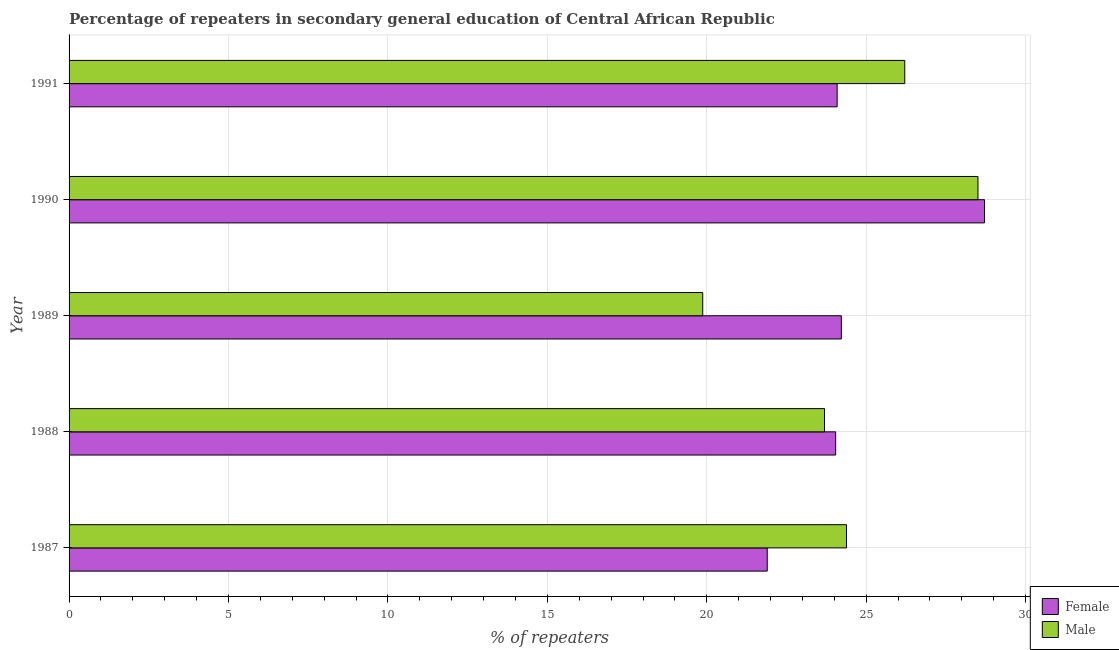How many different coloured bars are there?
Provide a succinct answer. 2. How many groups of bars are there?
Your response must be concise. 5. Are the number of bars per tick equal to the number of legend labels?
Provide a succinct answer. Yes. What is the percentage of female repeaters in 1988?
Provide a short and direct response. 24.04. Across all years, what is the maximum percentage of female repeaters?
Provide a short and direct response. 28.71. Across all years, what is the minimum percentage of female repeaters?
Ensure brevity in your answer.  21.9. What is the total percentage of female repeaters in the graph?
Your answer should be compact. 122.96. What is the difference between the percentage of female repeaters in 1987 and that in 1990?
Make the answer very short. -6.82. What is the difference between the percentage of female repeaters in 1990 and the percentage of male repeaters in 1991?
Offer a very short reply. 2.5. What is the average percentage of male repeaters per year?
Ensure brevity in your answer.  24.53. In the year 1991, what is the difference between the percentage of female repeaters and percentage of male repeaters?
Offer a terse response. -2.12. What is the ratio of the percentage of female repeaters in 1987 to that in 1989?
Ensure brevity in your answer.  0.9. What is the difference between the highest and the second highest percentage of female repeaters?
Ensure brevity in your answer.  4.49. What is the difference between the highest and the lowest percentage of female repeaters?
Your response must be concise. 6.82. What does the 2nd bar from the bottom in 1989 represents?
Make the answer very short. Male. How many years are there in the graph?
Keep it short and to the point. 5. Does the graph contain any zero values?
Your answer should be compact. No. Does the graph contain grids?
Your answer should be compact. Yes. What is the title of the graph?
Provide a short and direct response. Percentage of repeaters in secondary general education of Central African Republic. Does "DAC donors" appear as one of the legend labels in the graph?
Your answer should be very brief. No. What is the label or title of the X-axis?
Your response must be concise. % of repeaters. What is the % of repeaters in Female in 1987?
Ensure brevity in your answer.  21.9. What is the % of repeaters of Male in 1987?
Your answer should be compact. 24.38. What is the % of repeaters of Female in 1988?
Your response must be concise. 24.04. What is the % of repeaters of Male in 1988?
Your answer should be very brief. 23.69. What is the % of repeaters in Female in 1989?
Provide a succinct answer. 24.22. What is the % of repeaters of Male in 1989?
Provide a succinct answer. 19.87. What is the % of repeaters in Female in 1990?
Your answer should be very brief. 28.71. What is the % of repeaters of Male in 1990?
Give a very brief answer. 28.51. What is the % of repeaters of Female in 1991?
Give a very brief answer. 24.09. What is the % of repeaters of Male in 1991?
Make the answer very short. 26.21. Across all years, what is the maximum % of repeaters in Female?
Offer a terse response. 28.71. Across all years, what is the maximum % of repeaters in Male?
Keep it short and to the point. 28.51. Across all years, what is the minimum % of repeaters in Female?
Your response must be concise. 21.9. Across all years, what is the minimum % of repeaters of Male?
Your answer should be compact. 19.87. What is the total % of repeaters in Female in the graph?
Provide a short and direct response. 122.96. What is the total % of repeaters in Male in the graph?
Ensure brevity in your answer.  122.66. What is the difference between the % of repeaters of Female in 1987 and that in 1988?
Provide a succinct answer. -2.15. What is the difference between the % of repeaters of Male in 1987 and that in 1988?
Give a very brief answer. 0.69. What is the difference between the % of repeaters of Female in 1987 and that in 1989?
Keep it short and to the point. -2.32. What is the difference between the % of repeaters in Male in 1987 and that in 1989?
Provide a succinct answer. 4.51. What is the difference between the % of repeaters of Female in 1987 and that in 1990?
Give a very brief answer. -6.82. What is the difference between the % of repeaters of Male in 1987 and that in 1990?
Ensure brevity in your answer.  -4.12. What is the difference between the % of repeaters of Female in 1987 and that in 1991?
Your answer should be compact. -2.19. What is the difference between the % of repeaters of Male in 1987 and that in 1991?
Keep it short and to the point. -1.83. What is the difference between the % of repeaters in Female in 1988 and that in 1989?
Your answer should be very brief. -0.18. What is the difference between the % of repeaters of Male in 1988 and that in 1989?
Ensure brevity in your answer.  3.82. What is the difference between the % of repeaters of Female in 1988 and that in 1990?
Ensure brevity in your answer.  -4.67. What is the difference between the % of repeaters in Male in 1988 and that in 1990?
Ensure brevity in your answer.  -4.81. What is the difference between the % of repeaters of Female in 1988 and that in 1991?
Provide a short and direct response. -0.05. What is the difference between the % of repeaters in Male in 1988 and that in 1991?
Your response must be concise. -2.52. What is the difference between the % of repeaters of Female in 1989 and that in 1990?
Keep it short and to the point. -4.49. What is the difference between the % of repeaters of Male in 1989 and that in 1990?
Keep it short and to the point. -8.63. What is the difference between the % of repeaters in Female in 1989 and that in 1991?
Keep it short and to the point. 0.13. What is the difference between the % of repeaters of Male in 1989 and that in 1991?
Provide a short and direct response. -6.34. What is the difference between the % of repeaters in Female in 1990 and that in 1991?
Keep it short and to the point. 4.62. What is the difference between the % of repeaters in Male in 1990 and that in 1991?
Make the answer very short. 2.3. What is the difference between the % of repeaters in Female in 1987 and the % of repeaters in Male in 1988?
Your answer should be very brief. -1.8. What is the difference between the % of repeaters in Female in 1987 and the % of repeaters in Male in 1989?
Your response must be concise. 2.02. What is the difference between the % of repeaters of Female in 1987 and the % of repeaters of Male in 1990?
Your answer should be very brief. -6.61. What is the difference between the % of repeaters of Female in 1987 and the % of repeaters of Male in 1991?
Offer a terse response. -4.31. What is the difference between the % of repeaters of Female in 1988 and the % of repeaters of Male in 1989?
Offer a terse response. 4.17. What is the difference between the % of repeaters in Female in 1988 and the % of repeaters in Male in 1990?
Provide a succinct answer. -4.46. What is the difference between the % of repeaters in Female in 1988 and the % of repeaters in Male in 1991?
Offer a very short reply. -2.17. What is the difference between the % of repeaters in Female in 1989 and the % of repeaters in Male in 1990?
Offer a very short reply. -4.29. What is the difference between the % of repeaters in Female in 1989 and the % of repeaters in Male in 1991?
Your answer should be very brief. -1.99. What is the difference between the % of repeaters of Female in 1990 and the % of repeaters of Male in 1991?
Offer a terse response. 2.5. What is the average % of repeaters of Female per year?
Your answer should be compact. 24.59. What is the average % of repeaters in Male per year?
Offer a very short reply. 24.53. In the year 1987, what is the difference between the % of repeaters of Female and % of repeaters of Male?
Offer a terse response. -2.49. In the year 1988, what is the difference between the % of repeaters in Female and % of repeaters in Male?
Make the answer very short. 0.35. In the year 1989, what is the difference between the % of repeaters in Female and % of repeaters in Male?
Your answer should be very brief. 4.35. In the year 1990, what is the difference between the % of repeaters of Female and % of repeaters of Male?
Provide a short and direct response. 0.21. In the year 1991, what is the difference between the % of repeaters in Female and % of repeaters in Male?
Your answer should be compact. -2.12. What is the ratio of the % of repeaters of Female in 1987 to that in 1988?
Give a very brief answer. 0.91. What is the ratio of the % of repeaters of Male in 1987 to that in 1988?
Offer a very short reply. 1.03. What is the ratio of the % of repeaters of Female in 1987 to that in 1989?
Provide a short and direct response. 0.9. What is the ratio of the % of repeaters of Male in 1987 to that in 1989?
Offer a very short reply. 1.23. What is the ratio of the % of repeaters in Female in 1987 to that in 1990?
Your answer should be compact. 0.76. What is the ratio of the % of repeaters in Male in 1987 to that in 1990?
Your answer should be very brief. 0.86. What is the ratio of the % of repeaters of Female in 1987 to that in 1991?
Provide a succinct answer. 0.91. What is the ratio of the % of repeaters in Male in 1987 to that in 1991?
Make the answer very short. 0.93. What is the ratio of the % of repeaters in Male in 1988 to that in 1989?
Provide a short and direct response. 1.19. What is the ratio of the % of repeaters of Female in 1988 to that in 1990?
Ensure brevity in your answer.  0.84. What is the ratio of the % of repeaters in Male in 1988 to that in 1990?
Provide a short and direct response. 0.83. What is the ratio of the % of repeaters of Male in 1988 to that in 1991?
Your response must be concise. 0.9. What is the ratio of the % of repeaters in Female in 1989 to that in 1990?
Your answer should be compact. 0.84. What is the ratio of the % of repeaters of Male in 1989 to that in 1990?
Your answer should be very brief. 0.7. What is the ratio of the % of repeaters of Female in 1989 to that in 1991?
Offer a terse response. 1.01. What is the ratio of the % of repeaters in Male in 1989 to that in 1991?
Keep it short and to the point. 0.76. What is the ratio of the % of repeaters in Female in 1990 to that in 1991?
Keep it short and to the point. 1.19. What is the ratio of the % of repeaters of Male in 1990 to that in 1991?
Your answer should be very brief. 1.09. What is the difference between the highest and the second highest % of repeaters of Female?
Your answer should be compact. 4.49. What is the difference between the highest and the second highest % of repeaters of Male?
Provide a short and direct response. 2.3. What is the difference between the highest and the lowest % of repeaters in Female?
Ensure brevity in your answer.  6.82. What is the difference between the highest and the lowest % of repeaters of Male?
Provide a succinct answer. 8.63. 